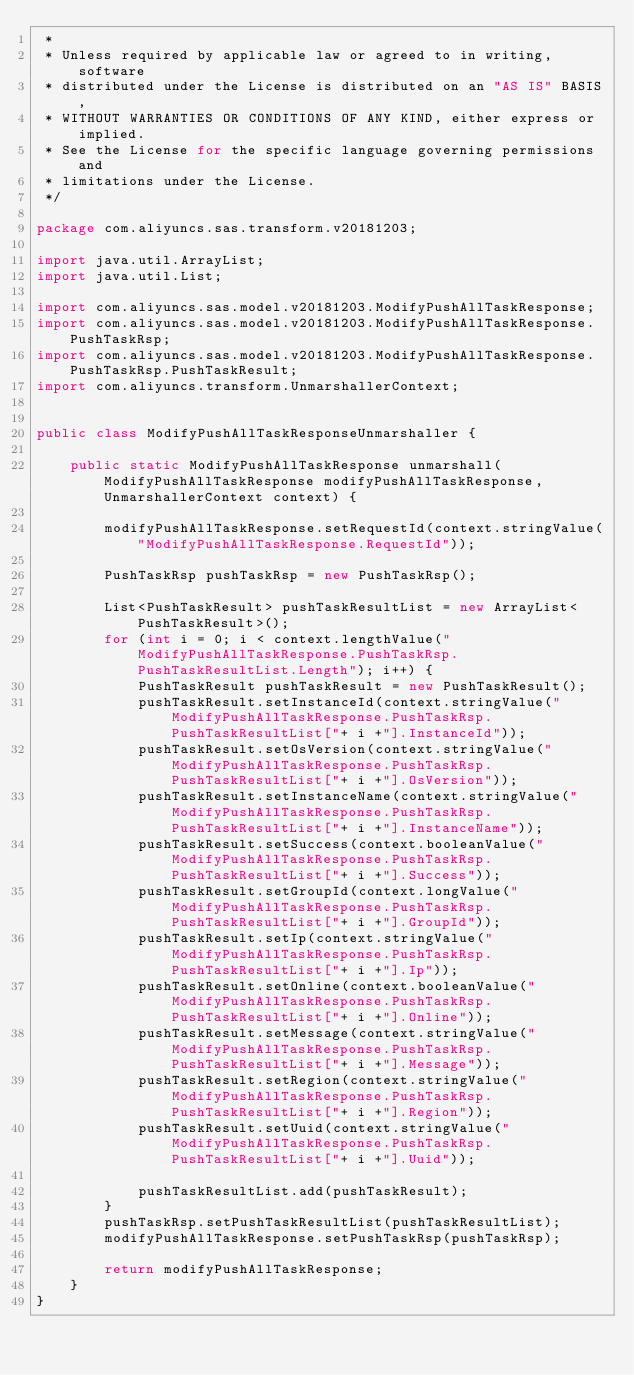Convert code to text. <code><loc_0><loc_0><loc_500><loc_500><_Java_> *
 * Unless required by applicable law or agreed to in writing, software
 * distributed under the License is distributed on an "AS IS" BASIS,
 * WITHOUT WARRANTIES OR CONDITIONS OF ANY KIND, either express or implied.
 * See the License for the specific language governing permissions and
 * limitations under the License.
 */

package com.aliyuncs.sas.transform.v20181203;

import java.util.ArrayList;
import java.util.List;

import com.aliyuncs.sas.model.v20181203.ModifyPushAllTaskResponse;
import com.aliyuncs.sas.model.v20181203.ModifyPushAllTaskResponse.PushTaskRsp;
import com.aliyuncs.sas.model.v20181203.ModifyPushAllTaskResponse.PushTaskRsp.PushTaskResult;
import com.aliyuncs.transform.UnmarshallerContext;


public class ModifyPushAllTaskResponseUnmarshaller {

	public static ModifyPushAllTaskResponse unmarshall(ModifyPushAllTaskResponse modifyPushAllTaskResponse, UnmarshallerContext context) {
		
		modifyPushAllTaskResponse.setRequestId(context.stringValue("ModifyPushAllTaskResponse.RequestId"));

		PushTaskRsp pushTaskRsp = new PushTaskRsp();

		List<PushTaskResult> pushTaskResultList = new ArrayList<PushTaskResult>();
		for (int i = 0; i < context.lengthValue("ModifyPushAllTaskResponse.PushTaskRsp.PushTaskResultList.Length"); i++) {
			PushTaskResult pushTaskResult = new PushTaskResult();
			pushTaskResult.setInstanceId(context.stringValue("ModifyPushAllTaskResponse.PushTaskRsp.PushTaskResultList["+ i +"].InstanceId"));
			pushTaskResult.setOsVersion(context.stringValue("ModifyPushAllTaskResponse.PushTaskRsp.PushTaskResultList["+ i +"].OsVersion"));
			pushTaskResult.setInstanceName(context.stringValue("ModifyPushAllTaskResponse.PushTaskRsp.PushTaskResultList["+ i +"].InstanceName"));
			pushTaskResult.setSuccess(context.booleanValue("ModifyPushAllTaskResponse.PushTaskRsp.PushTaskResultList["+ i +"].Success"));
			pushTaskResult.setGroupId(context.longValue("ModifyPushAllTaskResponse.PushTaskRsp.PushTaskResultList["+ i +"].GroupId"));
			pushTaskResult.setIp(context.stringValue("ModifyPushAllTaskResponse.PushTaskRsp.PushTaskResultList["+ i +"].Ip"));
			pushTaskResult.setOnline(context.booleanValue("ModifyPushAllTaskResponse.PushTaskRsp.PushTaskResultList["+ i +"].Online"));
			pushTaskResult.setMessage(context.stringValue("ModifyPushAllTaskResponse.PushTaskRsp.PushTaskResultList["+ i +"].Message"));
			pushTaskResult.setRegion(context.stringValue("ModifyPushAllTaskResponse.PushTaskRsp.PushTaskResultList["+ i +"].Region"));
			pushTaskResult.setUuid(context.stringValue("ModifyPushAllTaskResponse.PushTaskRsp.PushTaskResultList["+ i +"].Uuid"));

			pushTaskResultList.add(pushTaskResult);
		}
		pushTaskRsp.setPushTaskResultList(pushTaskResultList);
		modifyPushAllTaskResponse.setPushTaskRsp(pushTaskRsp);
	 
	 	return modifyPushAllTaskResponse;
	}
}</code> 